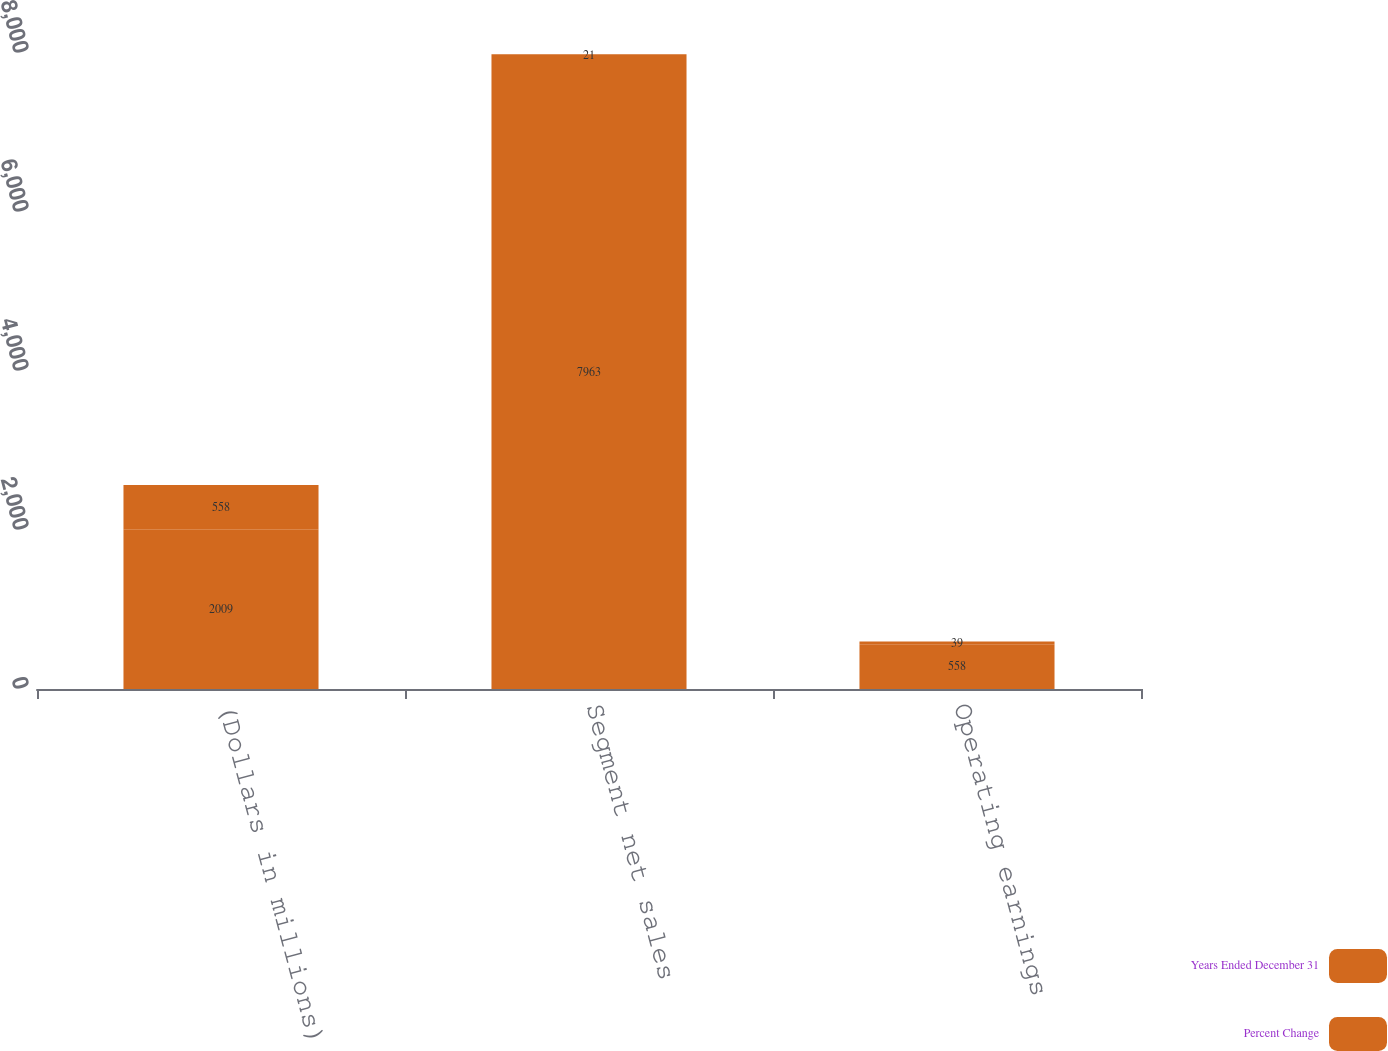Convert chart to OTSL. <chart><loc_0><loc_0><loc_500><loc_500><stacked_bar_chart><ecel><fcel>(Dollars in millions)<fcel>Segment net sales<fcel>Operating earnings<nl><fcel>Years Ended December 31<fcel>2009<fcel>7963<fcel>558<nl><fcel>Percent Change<fcel>558<fcel>21<fcel>39<nl></chart> 